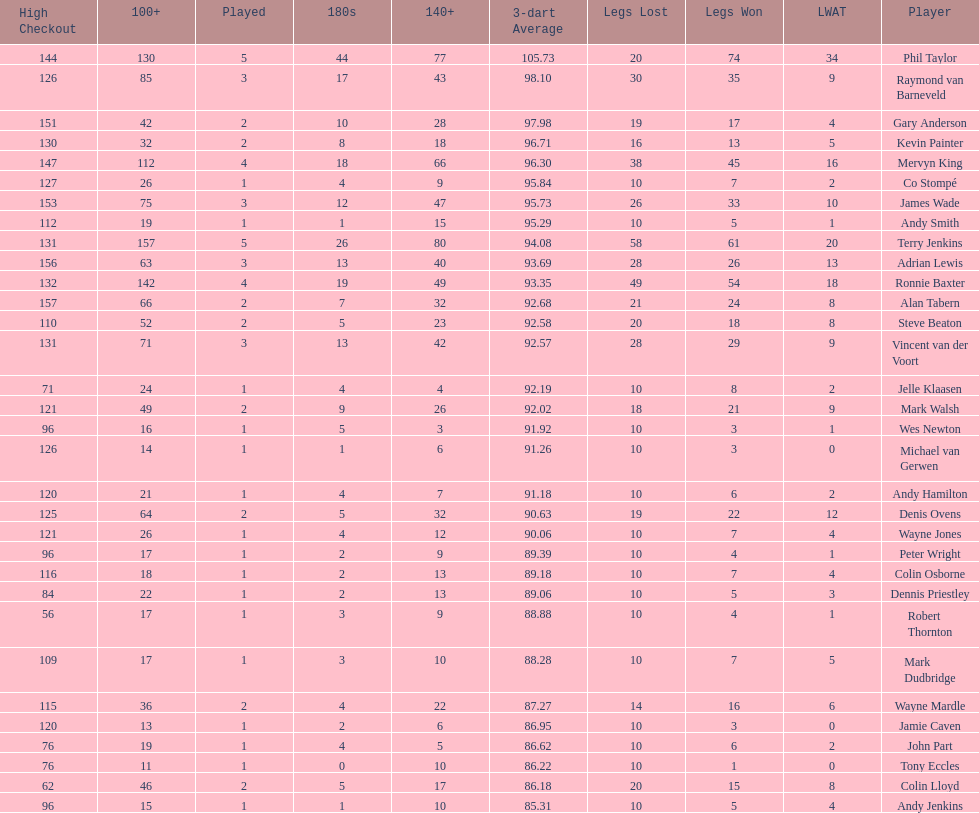How many players have a 3 dart average of more than 97? 3. 